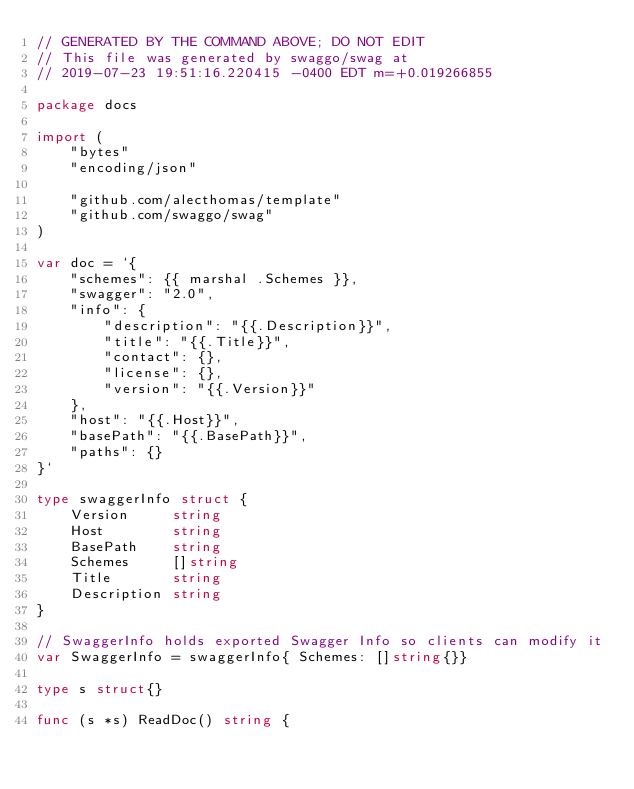<code> <loc_0><loc_0><loc_500><loc_500><_Go_>// GENERATED BY THE COMMAND ABOVE; DO NOT EDIT
// This file was generated by swaggo/swag at
// 2019-07-23 19:51:16.220415 -0400 EDT m=+0.019266855

package docs

import (
	"bytes"
	"encoding/json"

	"github.com/alecthomas/template"
	"github.com/swaggo/swag"
)

var doc = `{
    "schemes": {{ marshal .Schemes }},
    "swagger": "2.0",
    "info": {
        "description": "{{.Description}}",
        "title": "{{.Title}}",
        "contact": {},
        "license": {},
        "version": "{{.Version}}"
    },
    "host": "{{.Host}}",
    "basePath": "{{.BasePath}}",
    "paths": {}
}`

type swaggerInfo struct {
	Version     string
	Host        string
	BasePath    string
	Schemes     []string
	Title       string
	Description string
}

// SwaggerInfo holds exported Swagger Info so clients can modify it
var SwaggerInfo = swaggerInfo{ Schemes: []string{}}

type s struct{}

func (s *s) ReadDoc() string {</code> 